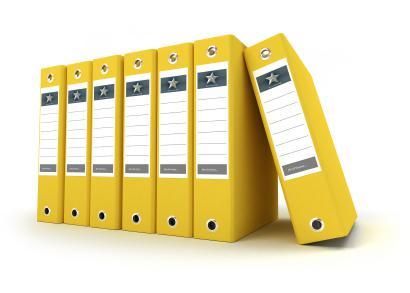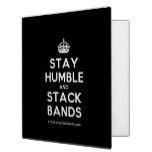The first image is the image on the left, the second image is the image on the right. Given the left and right images, does the statement "There are four storage books of the same color in the left image." hold true? Answer yes or no. No. 